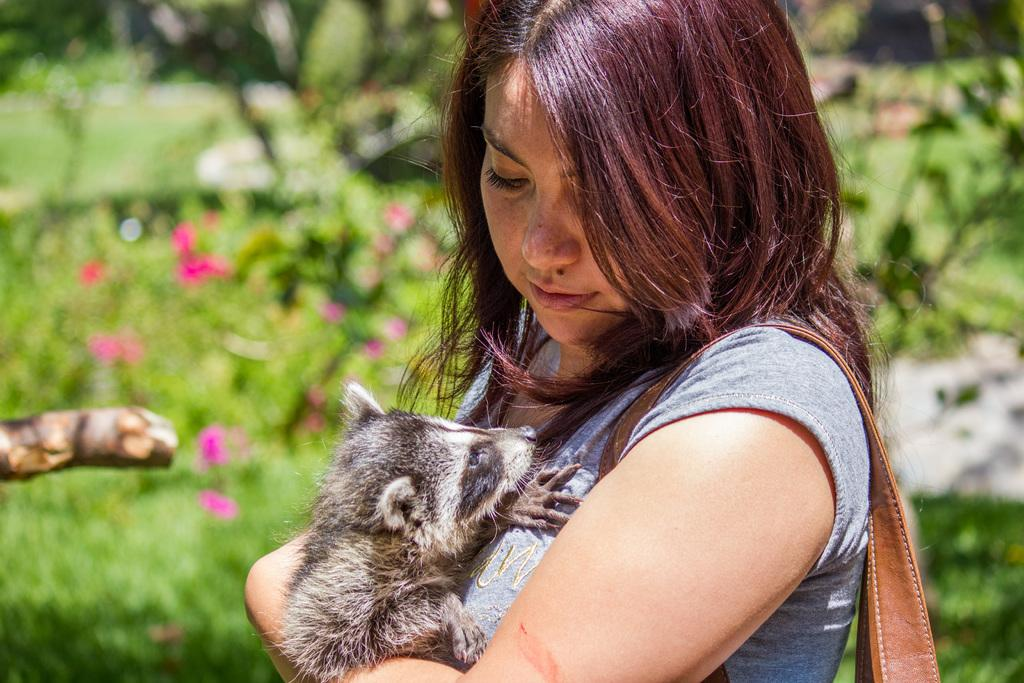Who is the main subject in the image? There is a woman standing in the front of the image. What is the woman holding in her hand? The woman is holding an animal in her hand. What can be seen in the background of the image? There are plants and flowers in the background of the image. What type of match does the woman use to light the animal in the image? There is no match or any indication of lighting in the image. The woman is simply holding an animal in her hand. 